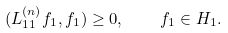Convert formula to latex. <formula><loc_0><loc_0><loc_500><loc_500>( L ^ { ( n ) } _ { 1 1 } f _ { 1 } , f _ { 1 } ) \geq 0 , \quad f _ { 1 } \in H _ { 1 } .</formula> 